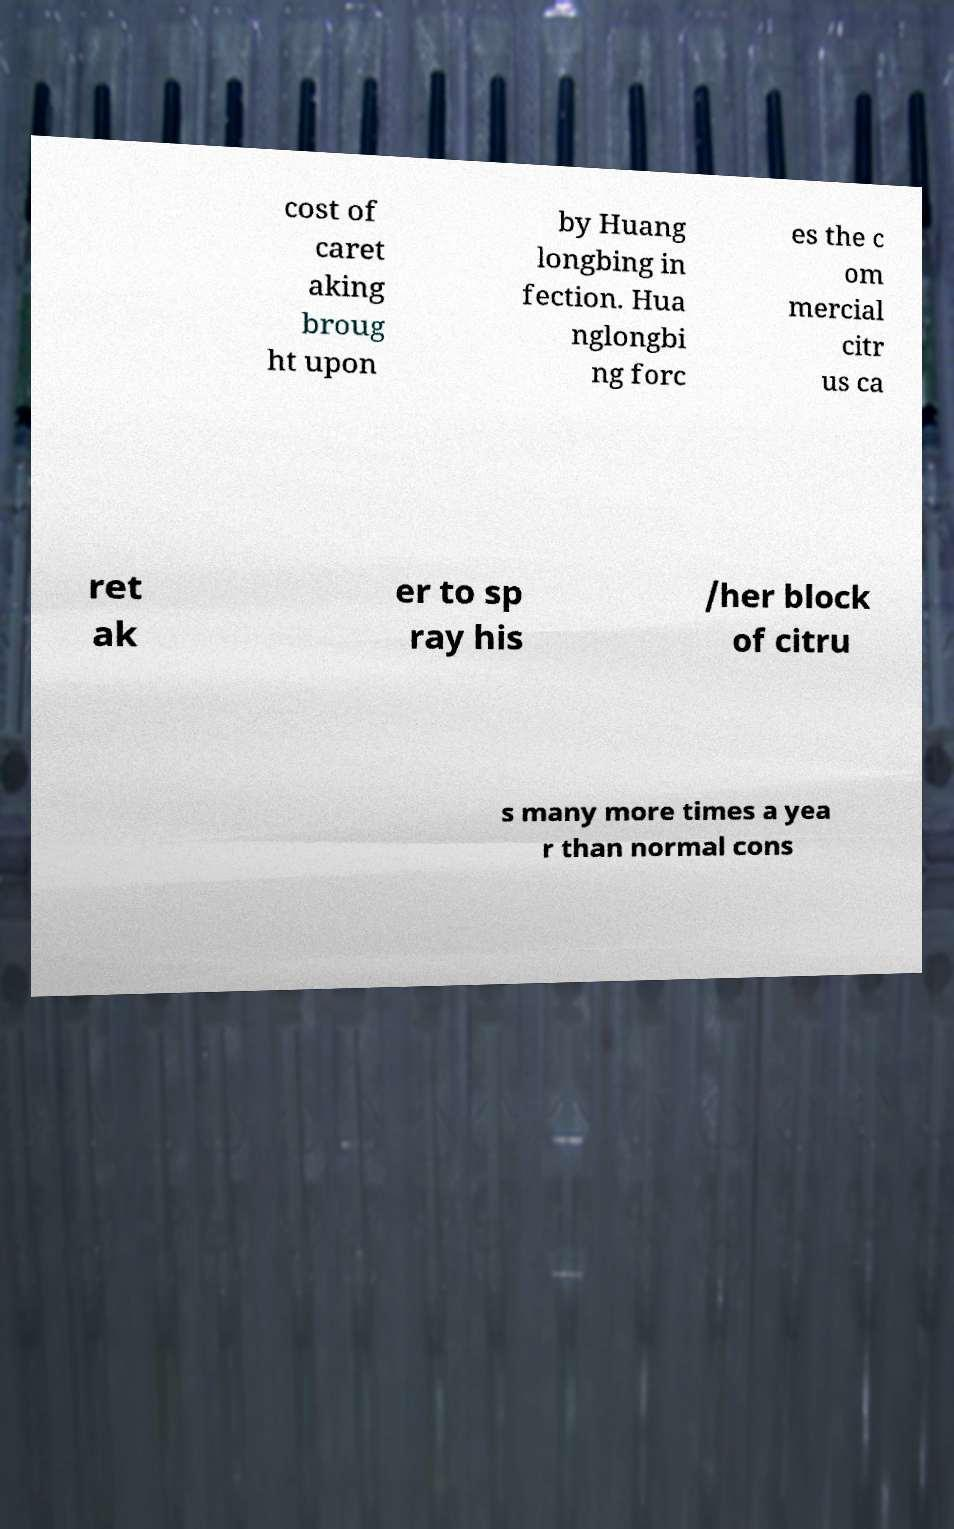Can you read and provide the text displayed in the image?This photo seems to have some interesting text. Can you extract and type it out for me? cost of caret aking broug ht upon by Huang longbing in fection. Hua nglongbi ng forc es the c om mercial citr us ca ret ak er to sp ray his /her block of citru s many more times a yea r than normal cons 